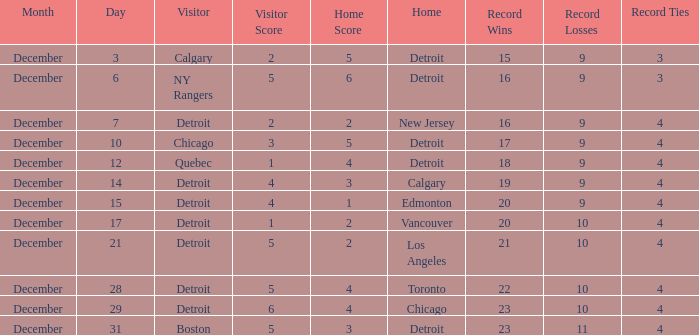What is the score on december 10? 3 – 5. 